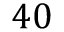Convert formula to latex. <formula><loc_0><loc_0><loc_500><loc_500>4 0</formula> 